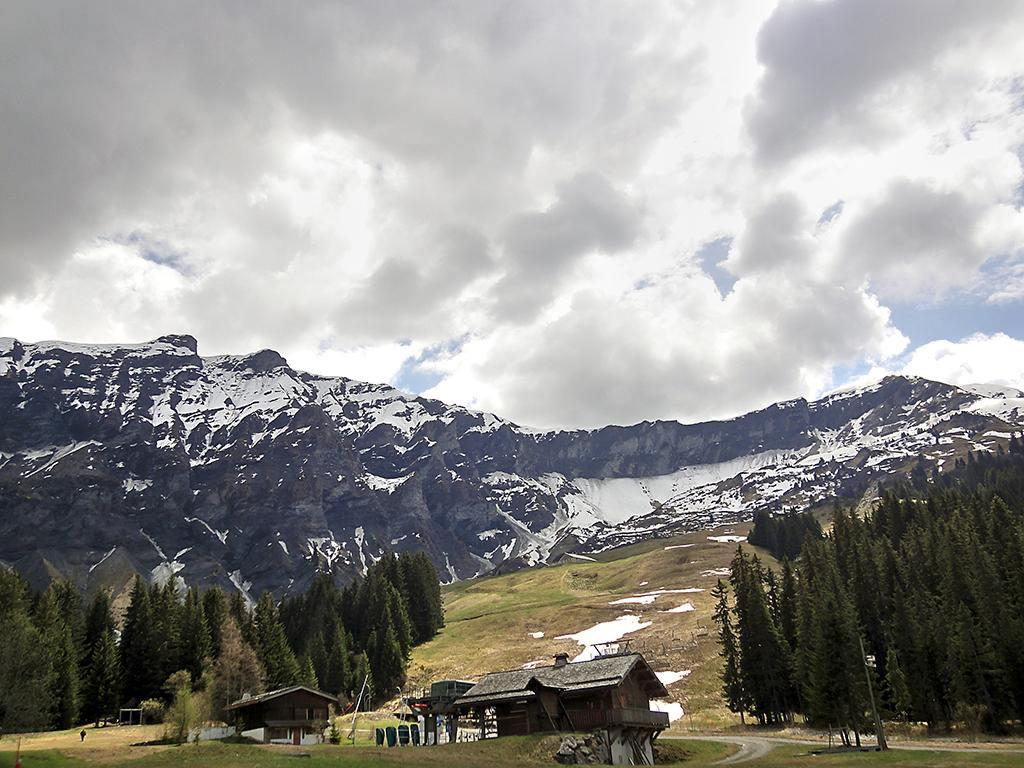What can be seen in the foreground of the image? There are houses and a road in the foreground of the image. What type of vegetation is present in the background of the image? There are alpine trees in the background of the image. What natural features can be seen in the background of the image? There are snow-covered mountains in the background of the image. What is the condition of the sky in the background of the image? The sky is cloudy in the background of the image. What type of furniture can be seen in the image? There is no furniture present in the image; it features houses, a road, alpine trees, snow-covered mountains, and a cloudy sky. How many rings are visible on the snow-covered mountains in the image? There are no rings present on the snow-covered mountains in the image. 